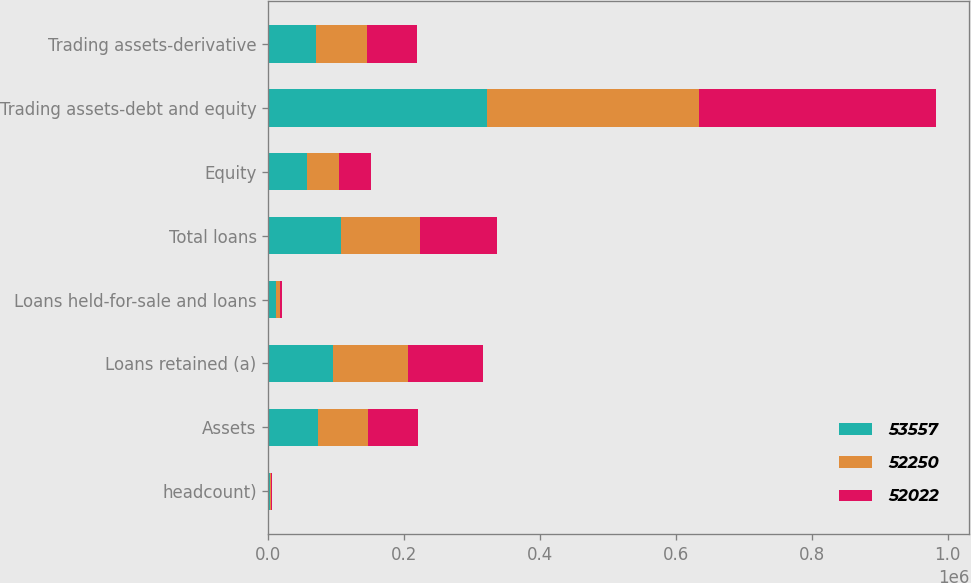Convert chart to OTSL. <chart><loc_0><loc_0><loc_500><loc_500><stacked_bar_chart><ecel><fcel>headcount)<fcel>Assets<fcel>Loans retained (a)<fcel>Loans held-for-sale and loans<fcel>Total loans<fcel>Equity<fcel>Trading assets-debt and equity<fcel>Trading assets-derivative<nl><fcel>53557<fcel>2013<fcel>73200<fcel>95627<fcel>11913<fcel>107540<fcel>56500<fcel>321585<fcel>70353<nl><fcel>52250<fcel>2012<fcel>73200<fcel>109501<fcel>5749<fcel>115250<fcel>47500<fcel>312944<fcel>74874<nl><fcel>52022<fcel>2011<fcel>73200<fcel>111099<fcel>3016<fcel>114115<fcel>47000<fcel>348234<fcel>73200<nl></chart> 